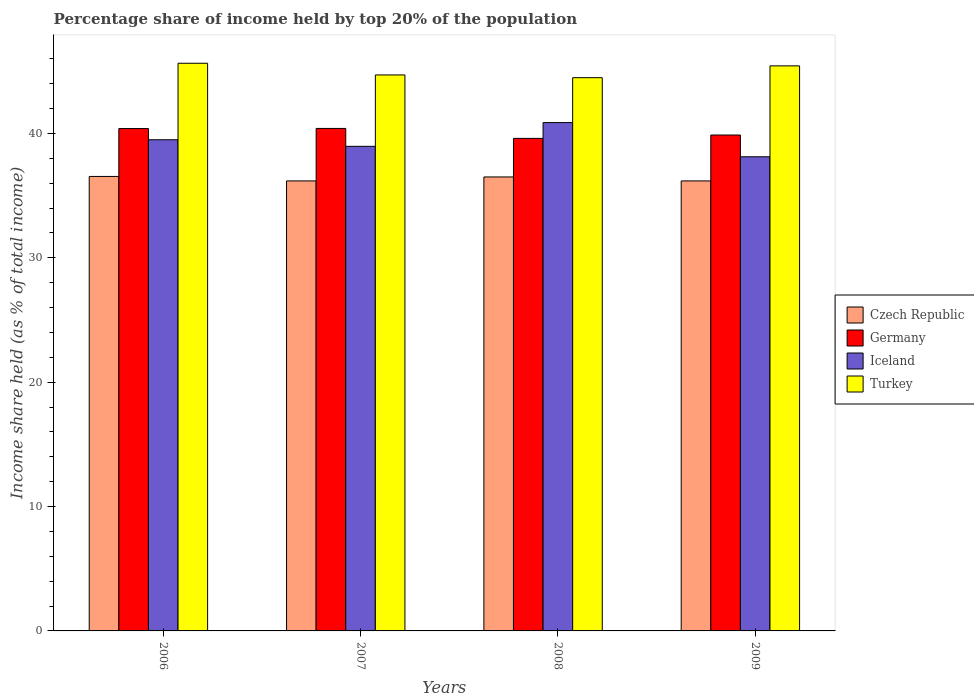How many bars are there on the 2nd tick from the left?
Your answer should be compact. 4. How many bars are there on the 3rd tick from the right?
Ensure brevity in your answer.  4. What is the label of the 4th group of bars from the left?
Offer a terse response. 2009. What is the percentage share of income held by top 20% of the population in Turkey in 2009?
Your answer should be very brief. 45.43. Across all years, what is the maximum percentage share of income held by top 20% of the population in Turkey?
Make the answer very short. 45.64. Across all years, what is the minimum percentage share of income held by top 20% of the population in Iceland?
Your answer should be very brief. 38.12. In which year was the percentage share of income held by top 20% of the population in Turkey minimum?
Make the answer very short. 2008. What is the total percentage share of income held by top 20% of the population in Czech Republic in the graph?
Offer a very short reply. 145.4. What is the difference between the percentage share of income held by top 20% of the population in Iceland in 2008 and that in 2009?
Your answer should be compact. 2.75. What is the difference between the percentage share of income held by top 20% of the population in Germany in 2008 and the percentage share of income held by top 20% of the population in Iceland in 2009?
Provide a succinct answer. 1.48. What is the average percentage share of income held by top 20% of the population in Turkey per year?
Provide a succinct answer. 45.06. In the year 2008, what is the difference between the percentage share of income held by top 20% of the population in Czech Republic and percentage share of income held by top 20% of the population in Germany?
Provide a succinct answer. -3.1. What is the ratio of the percentage share of income held by top 20% of the population in Czech Republic in 2008 to that in 2009?
Give a very brief answer. 1.01. Is the percentage share of income held by top 20% of the population in Czech Republic in 2008 less than that in 2009?
Give a very brief answer. No. What is the difference between the highest and the second highest percentage share of income held by top 20% of the population in Germany?
Provide a short and direct response. 0.01. What is the difference between the highest and the lowest percentage share of income held by top 20% of the population in Iceland?
Offer a terse response. 2.75. Is the sum of the percentage share of income held by top 20% of the population in Germany in 2006 and 2008 greater than the maximum percentage share of income held by top 20% of the population in Turkey across all years?
Give a very brief answer. Yes. Is it the case that in every year, the sum of the percentage share of income held by top 20% of the population in Turkey and percentage share of income held by top 20% of the population in Germany is greater than the sum of percentage share of income held by top 20% of the population in Iceland and percentage share of income held by top 20% of the population in Czech Republic?
Provide a short and direct response. Yes. What does the 1st bar from the left in 2008 represents?
Offer a very short reply. Czech Republic. Is it the case that in every year, the sum of the percentage share of income held by top 20% of the population in Germany and percentage share of income held by top 20% of the population in Turkey is greater than the percentage share of income held by top 20% of the population in Czech Republic?
Your answer should be very brief. Yes. How many years are there in the graph?
Your answer should be compact. 4. Are the values on the major ticks of Y-axis written in scientific E-notation?
Your response must be concise. No. Does the graph contain grids?
Ensure brevity in your answer.  No. Where does the legend appear in the graph?
Offer a terse response. Center right. How many legend labels are there?
Keep it short and to the point. 4. How are the legend labels stacked?
Provide a succinct answer. Vertical. What is the title of the graph?
Provide a short and direct response. Percentage share of income held by top 20% of the population. What is the label or title of the Y-axis?
Your answer should be very brief. Income share held (as % of total income). What is the Income share held (as % of total income) of Czech Republic in 2006?
Ensure brevity in your answer.  36.54. What is the Income share held (as % of total income) in Germany in 2006?
Make the answer very short. 40.39. What is the Income share held (as % of total income) in Iceland in 2006?
Your answer should be compact. 39.49. What is the Income share held (as % of total income) of Turkey in 2006?
Ensure brevity in your answer.  45.64. What is the Income share held (as % of total income) in Czech Republic in 2007?
Make the answer very short. 36.18. What is the Income share held (as % of total income) in Germany in 2007?
Provide a succinct answer. 40.4. What is the Income share held (as % of total income) of Iceland in 2007?
Ensure brevity in your answer.  38.96. What is the Income share held (as % of total income) of Turkey in 2007?
Provide a short and direct response. 44.7. What is the Income share held (as % of total income) of Czech Republic in 2008?
Make the answer very short. 36.5. What is the Income share held (as % of total income) in Germany in 2008?
Provide a succinct answer. 39.6. What is the Income share held (as % of total income) of Iceland in 2008?
Provide a succinct answer. 40.87. What is the Income share held (as % of total income) of Turkey in 2008?
Give a very brief answer. 44.48. What is the Income share held (as % of total income) of Czech Republic in 2009?
Your response must be concise. 36.18. What is the Income share held (as % of total income) of Germany in 2009?
Your response must be concise. 39.87. What is the Income share held (as % of total income) in Iceland in 2009?
Offer a terse response. 38.12. What is the Income share held (as % of total income) in Turkey in 2009?
Offer a very short reply. 45.43. Across all years, what is the maximum Income share held (as % of total income) of Czech Republic?
Make the answer very short. 36.54. Across all years, what is the maximum Income share held (as % of total income) in Germany?
Offer a terse response. 40.4. Across all years, what is the maximum Income share held (as % of total income) in Iceland?
Offer a terse response. 40.87. Across all years, what is the maximum Income share held (as % of total income) in Turkey?
Give a very brief answer. 45.64. Across all years, what is the minimum Income share held (as % of total income) of Czech Republic?
Your answer should be very brief. 36.18. Across all years, what is the minimum Income share held (as % of total income) of Germany?
Offer a terse response. 39.6. Across all years, what is the minimum Income share held (as % of total income) in Iceland?
Provide a short and direct response. 38.12. Across all years, what is the minimum Income share held (as % of total income) in Turkey?
Provide a succinct answer. 44.48. What is the total Income share held (as % of total income) in Czech Republic in the graph?
Your answer should be very brief. 145.4. What is the total Income share held (as % of total income) of Germany in the graph?
Your answer should be very brief. 160.26. What is the total Income share held (as % of total income) in Iceland in the graph?
Ensure brevity in your answer.  157.44. What is the total Income share held (as % of total income) of Turkey in the graph?
Make the answer very short. 180.25. What is the difference between the Income share held (as % of total income) in Czech Republic in 2006 and that in 2007?
Your response must be concise. 0.36. What is the difference between the Income share held (as % of total income) in Germany in 2006 and that in 2007?
Ensure brevity in your answer.  -0.01. What is the difference between the Income share held (as % of total income) in Iceland in 2006 and that in 2007?
Provide a short and direct response. 0.53. What is the difference between the Income share held (as % of total income) of Czech Republic in 2006 and that in 2008?
Provide a short and direct response. 0.04. What is the difference between the Income share held (as % of total income) of Germany in 2006 and that in 2008?
Your answer should be very brief. 0.79. What is the difference between the Income share held (as % of total income) in Iceland in 2006 and that in 2008?
Ensure brevity in your answer.  -1.38. What is the difference between the Income share held (as % of total income) of Turkey in 2006 and that in 2008?
Ensure brevity in your answer.  1.16. What is the difference between the Income share held (as % of total income) of Czech Republic in 2006 and that in 2009?
Offer a very short reply. 0.36. What is the difference between the Income share held (as % of total income) of Germany in 2006 and that in 2009?
Your answer should be compact. 0.52. What is the difference between the Income share held (as % of total income) of Iceland in 2006 and that in 2009?
Make the answer very short. 1.37. What is the difference between the Income share held (as % of total income) of Turkey in 2006 and that in 2009?
Your response must be concise. 0.21. What is the difference between the Income share held (as % of total income) in Czech Republic in 2007 and that in 2008?
Your answer should be very brief. -0.32. What is the difference between the Income share held (as % of total income) of Germany in 2007 and that in 2008?
Give a very brief answer. 0.8. What is the difference between the Income share held (as % of total income) in Iceland in 2007 and that in 2008?
Offer a terse response. -1.91. What is the difference between the Income share held (as % of total income) in Turkey in 2007 and that in 2008?
Make the answer very short. 0.22. What is the difference between the Income share held (as % of total income) in Germany in 2007 and that in 2009?
Keep it short and to the point. 0.53. What is the difference between the Income share held (as % of total income) in Iceland in 2007 and that in 2009?
Your answer should be very brief. 0.84. What is the difference between the Income share held (as % of total income) of Turkey in 2007 and that in 2009?
Your answer should be very brief. -0.73. What is the difference between the Income share held (as % of total income) of Czech Republic in 2008 and that in 2009?
Offer a very short reply. 0.32. What is the difference between the Income share held (as % of total income) in Germany in 2008 and that in 2009?
Ensure brevity in your answer.  -0.27. What is the difference between the Income share held (as % of total income) in Iceland in 2008 and that in 2009?
Keep it short and to the point. 2.75. What is the difference between the Income share held (as % of total income) of Turkey in 2008 and that in 2009?
Ensure brevity in your answer.  -0.95. What is the difference between the Income share held (as % of total income) of Czech Republic in 2006 and the Income share held (as % of total income) of Germany in 2007?
Your response must be concise. -3.86. What is the difference between the Income share held (as % of total income) in Czech Republic in 2006 and the Income share held (as % of total income) in Iceland in 2007?
Keep it short and to the point. -2.42. What is the difference between the Income share held (as % of total income) in Czech Republic in 2006 and the Income share held (as % of total income) in Turkey in 2007?
Ensure brevity in your answer.  -8.16. What is the difference between the Income share held (as % of total income) of Germany in 2006 and the Income share held (as % of total income) of Iceland in 2007?
Ensure brevity in your answer.  1.43. What is the difference between the Income share held (as % of total income) of Germany in 2006 and the Income share held (as % of total income) of Turkey in 2007?
Provide a succinct answer. -4.31. What is the difference between the Income share held (as % of total income) in Iceland in 2006 and the Income share held (as % of total income) in Turkey in 2007?
Your answer should be very brief. -5.21. What is the difference between the Income share held (as % of total income) in Czech Republic in 2006 and the Income share held (as % of total income) in Germany in 2008?
Offer a terse response. -3.06. What is the difference between the Income share held (as % of total income) of Czech Republic in 2006 and the Income share held (as % of total income) of Iceland in 2008?
Your answer should be very brief. -4.33. What is the difference between the Income share held (as % of total income) in Czech Republic in 2006 and the Income share held (as % of total income) in Turkey in 2008?
Ensure brevity in your answer.  -7.94. What is the difference between the Income share held (as % of total income) in Germany in 2006 and the Income share held (as % of total income) in Iceland in 2008?
Ensure brevity in your answer.  -0.48. What is the difference between the Income share held (as % of total income) in Germany in 2006 and the Income share held (as % of total income) in Turkey in 2008?
Keep it short and to the point. -4.09. What is the difference between the Income share held (as % of total income) in Iceland in 2006 and the Income share held (as % of total income) in Turkey in 2008?
Keep it short and to the point. -4.99. What is the difference between the Income share held (as % of total income) of Czech Republic in 2006 and the Income share held (as % of total income) of Germany in 2009?
Ensure brevity in your answer.  -3.33. What is the difference between the Income share held (as % of total income) in Czech Republic in 2006 and the Income share held (as % of total income) in Iceland in 2009?
Provide a succinct answer. -1.58. What is the difference between the Income share held (as % of total income) of Czech Republic in 2006 and the Income share held (as % of total income) of Turkey in 2009?
Provide a short and direct response. -8.89. What is the difference between the Income share held (as % of total income) of Germany in 2006 and the Income share held (as % of total income) of Iceland in 2009?
Your answer should be compact. 2.27. What is the difference between the Income share held (as % of total income) of Germany in 2006 and the Income share held (as % of total income) of Turkey in 2009?
Your answer should be compact. -5.04. What is the difference between the Income share held (as % of total income) in Iceland in 2006 and the Income share held (as % of total income) in Turkey in 2009?
Ensure brevity in your answer.  -5.94. What is the difference between the Income share held (as % of total income) of Czech Republic in 2007 and the Income share held (as % of total income) of Germany in 2008?
Keep it short and to the point. -3.42. What is the difference between the Income share held (as % of total income) of Czech Republic in 2007 and the Income share held (as % of total income) of Iceland in 2008?
Ensure brevity in your answer.  -4.69. What is the difference between the Income share held (as % of total income) of Germany in 2007 and the Income share held (as % of total income) of Iceland in 2008?
Your response must be concise. -0.47. What is the difference between the Income share held (as % of total income) of Germany in 2007 and the Income share held (as % of total income) of Turkey in 2008?
Your answer should be compact. -4.08. What is the difference between the Income share held (as % of total income) of Iceland in 2007 and the Income share held (as % of total income) of Turkey in 2008?
Your answer should be compact. -5.52. What is the difference between the Income share held (as % of total income) in Czech Republic in 2007 and the Income share held (as % of total income) in Germany in 2009?
Your answer should be compact. -3.69. What is the difference between the Income share held (as % of total income) of Czech Republic in 2007 and the Income share held (as % of total income) of Iceland in 2009?
Keep it short and to the point. -1.94. What is the difference between the Income share held (as % of total income) of Czech Republic in 2007 and the Income share held (as % of total income) of Turkey in 2009?
Your answer should be very brief. -9.25. What is the difference between the Income share held (as % of total income) in Germany in 2007 and the Income share held (as % of total income) in Iceland in 2009?
Your response must be concise. 2.28. What is the difference between the Income share held (as % of total income) of Germany in 2007 and the Income share held (as % of total income) of Turkey in 2009?
Offer a very short reply. -5.03. What is the difference between the Income share held (as % of total income) of Iceland in 2007 and the Income share held (as % of total income) of Turkey in 2009?
Your response must be concise. -6.47. What is the difference between the Income share held (as % of total income) in Czech Republic in 2008 and the Income share held (as % of total income) in Germany in 2009?
Your answer should be very brief. -3.37. What is the difference between the Income share held (as % of total income) in Czech Republic in 2008 and the Income share held (as % of total income) in Iceland in 2009?
Your answer should be compact. -1.62. What is the difference between the Income share held (as % of total income) of Czech Republic in 2008 and the Income share held (as % of total income) of Turkey in 2009?
Give a very brief answer. -8.93. What is the difference between the Income share held (as % of total income) in Germany in 2008 and the Income share held (as % of total income) in Iceland in 2009?
Offer a very short reply. 1.48. What is the difference between the Income share held (as % of total income) of Germany in 2008 and the Income share held (as % of total income) of Turkey in 2009?
Keep it short and to the point. -5.83. What is the difference between the Income share held (as % of total income) of Iceland in 2008 and the Income share held (as % of total income) of Turkey in 2009?
Make the answer very short. -4.56. What is the average Income share held (as % of total income) of Czech Republic per year?
Provide a succinct answer. 36.35. What is the average Income share held (as % of total income) in Germany per year?
Your response must be concise. 40.06. What is the average Income share held (as % of total income) of Iceland per year?
Offer a very short reply. 39.36. What is the average Income share held (as % of total income) in Turkey per year?
Make the answer very short. 45.06. In the year 2006, what is the difference between the Income share held (as % of total income) of Czech Republic and Income share held (as % of total income) of Germany?
Offer a terse response. -3.85. In the year 2006, what is the difference between the Income share held (as % of total income) in Czech Republic and Income share held (as % of total income) in Iceland?
Provide a succinct answer. -2.95. In the year 2006, what is the difference between the Income share held (as % of total income) of Germany and Income share held (as % of total income) of Turkey?
Keep it short and to the point. -5.25. In the year 2006, what is the difference between the Income share held (as % of total income) of Iceland and Income share held (as % of total income) of Turkey?
Make the answer very short. -6.15. In the year 2007, what is the difference between the Income share held (as % of total income) of Czech Republic and Income share held (as % of total income) of Germany?
Keep it short and to the point. -4.22. In the year 2007, what is the difference between the Income share held (as % of total income) in Czech Republic and Income share held (as % of total income) in Iceland?
Make the answer very short. -2.78. In the year 2007, what is the difference between the Income share held (as % of total income) of Czech Republic and Income share held (as % of total income) of Turkey?
Ensure brevity in your answer.  -8.52. In the year 2007, what is the difference between the Income share held (as % of total income) in Germany and Income share held (as % of total income) in Iceland?
Keep it short and to the point. 1.44. In the year 2007, what is the difference between the Income share held (as % of total income) of Iceland and Income share held (as % of total income) of Turkey?
Your answer should be compact. -5.74. In the year 2008, what is the difference between the Income share held (as % of total income) in Czech Republic and Income share held (as % of total income) in Germany?
Make the answer very short. -3.1. In the year 2008, what is the difference between the Income share held (as % of total income) in Czech Republic and Income share held (as % of total income) in Iceland?
Provide a succinct answer. -4.37. In the year 2008, what is the difference between the Income share held (as % of total income) of Czech Republic and Income share held (as % of total income) of Turkey?
Provide a succinct answer. -7.98. In the year 2008, what is the difference between the Income share held (as % of total income) of Germany and Income share held (as % of total income) of Iceland?
Offer a terse response. -1.27. In the year 2008, what is the difference between the Income share held (as % of total income) of Germany and Income share held (as % of total income) of Turkey?
Offer a very short reply. -4.88. In the year 2008, what is the difference between the Income share held (as % of total income) of Iceland and Income share held (as % of total income) of Turkey?
Give a very brief answer. -3.61. In the year 2009, what is the difference between the Income share held (as % of total income) in Czech Republic and Income share held (as % of total income) in Germany?
Give a very brief answer. -3.69. In the year 2009, what is the difference between the Income share held (as % of total income) of Czech Republic and Income share held (as % of total income) of Iceland?
Keep it short and to the point. -1.94. In the year 2009, what is the difference between the Income share held (as % of total income) of Czech Republic and Income share held (as % of total income) of Turkey?
Offer a very short reply. -9.25. In the year 2009, what is the difference between the Income share held (as % of total income) in Germany and Income share held (as % of total income) in Turkey?
Your response must be concise. -5.56. In the year 2009, what is the difference between the Income share held (as % of total income) of Iceland and Income share held (as % of total income) of Turkey?
Offer a very short reply. -7.31. What is the ratio of the Income share held (as % of total income) of Germany in 2006 to that in 2007?
Your answer should be compact. 1. What is the ratio of the Income share held (as % of total income) of Iceland in 2006 to that in 2007?
Offer a terse response. 1.01. What is the ratio of the Income share held (as % of total income) in Turkey in 2006 to that in 2007?
Your answer should be very brief. 1.02. What is the ratio of the Income share held (as % of total income) of Czech Republic in 2006 to that in 2008?
Your answer should be very brief. 1. What is the ratio of the Income share held (as % of total income) of Germany in 2006 to that in 2008?
Make the answer very short. 1.02. What is the ratio of the Income share held (as % of total income) in Iceland in 2006 to that in 2008?
Make the answer very short. 0.97. What is the ratio of the Income share held (as % of total income) in Turkey in 2006 to that in 2008?
Your answer should be compact. 1.03. What is the ratio of the Income share held (as % of total income) in Czech Republic in 2006 to that in 2009?
Your answer should be very brief. 1.01. What is the ratio of the Income share held (as % of total income) in Germany in 2006 to that in 2009?
Your answer should be very brief. 1.01. What is the ratio of the Income share held (as % of total income) in Iceland in 2006 to that in 2009?
Offer a terse response. 1.04. What is the ratio of the Income share held (as % of total income) in Germany in 2007 to that in 2008?
Offer a terse response. 1.02. What is the ratio of the Income share held (as % of total income) of Iceland in 2007 to that in 2008?
Offer a terse response. 0.95. What is the ratio of the Income share held (as % of total income) in Germany in 2007 to that in 2009?
Make the answer very short. 1.01. What is the ratio of the Income share held (as % of total income) in Iceland in 2007 to that in 2009?
Offer a terse response. 1.02. What is the ratio of the Income share held (as % of total income) of Turkey in 2007 to that in 2009?
Offer a very short reply. 0.98. What is the ratio of the Income share held (as % of total income) of Czech Republic in 2008 to that in 2009?
Keep it short and to the point. 1.01. What is the ratio of the Income share held (as % of total income) in Germany in 2008 to that in 2009?
Provide a short and direct response. 0.99. What is the ratio of the Income share held (as % of total income) in Iceland in 2008 to that in 2009?
Your answer should be compact. 1.07. What is the ratio of the Income share held (as % of total income) of Turkey in 2008 to that in 2009?
Provide a short and direct response. 0.98. What is the difference between the highest and the second highest Income share held (as % of total income) in Czech Republic?
Keep it short and to the point. 0.04. What is the difference between the highest and the second highest Income share held (as % of total income) of Germany?
Ensure brevity in your answer.  0.01. What is the difference between the highest and the second highest Income share held (as % of total income) of Iceland?
Make the answer very short. 1.38. What is the difference between the highest and the second highest Income share held (as % of total income) in Turkey?
Keep it short and to the point. 0.21. What is the difference between the highest and the lowest Income share held (as % of total income) in Czech Republic?
Ensure brevity in your answer.  0.36. What is the difference between the highest and the lowest Income share held (as % of total income) of Germany?
Provide a short and direct response. 0.8. What is the difference between the highest and the lowest Income share held (as % of total income) of Iceland?
Provide a succinct answer. 2.75. What is the difference between the highest and the lowest Income share held (as % of total income) in Turkey?
Provide a short and direct response. 1.16. 